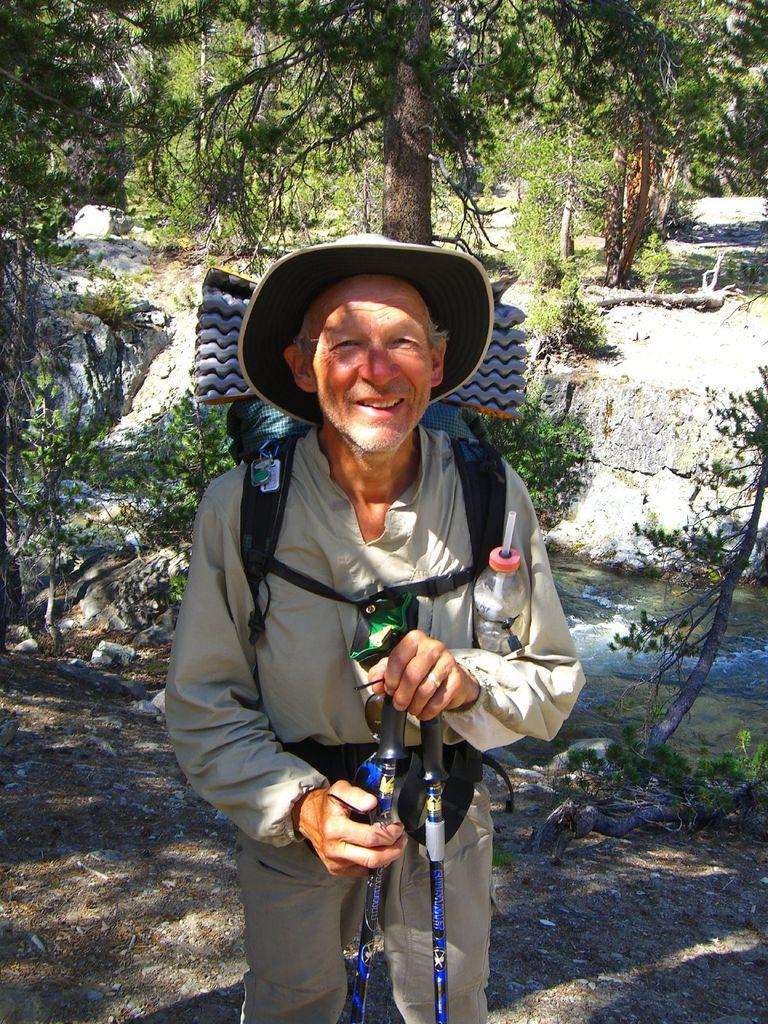Who is present in the image? There is a man in the image. What is the man wearing on his head? The man is wearing a hat. What type of clothing is the man wearing? The man is wearing clothes. What is the man holding in the image? The man is holding an object. What type of natural environment can be seen in the image? There are trees in the image. What type of dress is the ant wearing in the image? There is no ant present in the image, and therefore no such attire can be observed. 